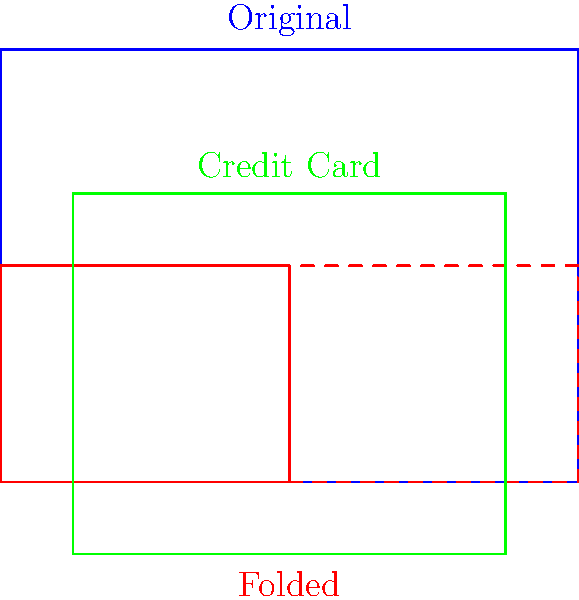A digital document needs to be folded to fit the dimensions of a credit card for a new mobile banking app. The original document measures 8 cm by 6 cm, while a standard credit card measures 8.5 cm by 5.4 cm. If the document is folded once to match the width of the credit card, what will be the resulting height of the folded document in centimeters? To solve this problem, let's follow these steps:

1. Identify the given dimensions:
   - Original document: 8 cm x 6 cm
   - Credit card: 8.5 cm x 5.4 cm

2. Determine the folding method:
   - The document needs to be folded once to match the width of the credit card.

3. Calculate the new width of the folded document:
   - New width = Original width ÷ 2
   - New width = 8 cm ÷ 2 = 4 cm

4. Calculate the height of the folded document:
   - Since we're only folding the width, the height remains unchanged.
   - Folded height = Original height = 6 cm

5. Compare the folded dimensions to the credit card:
   - Folded document: 4 cm x 6 cm
   - Credit card: 8.5 cm x 5.4 cm

6. Verify the result:
   - The folded width (4 cm) is now less than the credit card width (8.5 cm).
   - The folded height (6 cm) is slightly larger than the credit card height (5.4 cm).

Therefore, the resulting height of the folded document is 6 cm.
Answer: 6 cm 